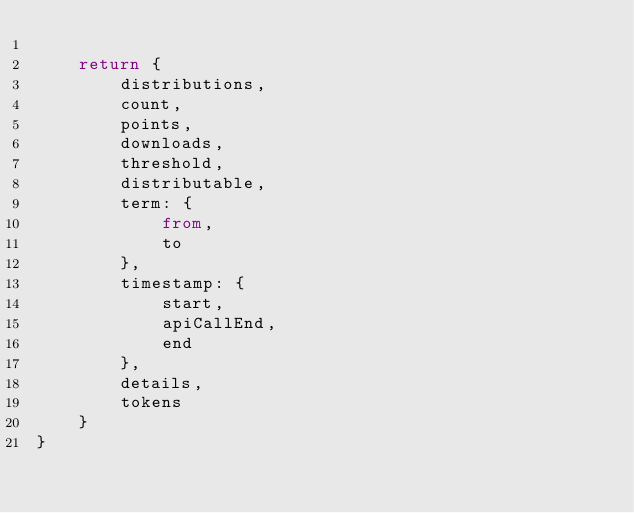Convert code to text. <code><loc_0><loc_0><loc_500><loc_500><_TypeScript_>
	return {
		distributions,
		count,
		points,
		downloads,
		threshold,
		distributable,
		term: {
			from,
			to
		},
		timestamp: {
			start,
			apiCallEnd,
			end
		},
		details,
		tokens
	}
}
</code> 